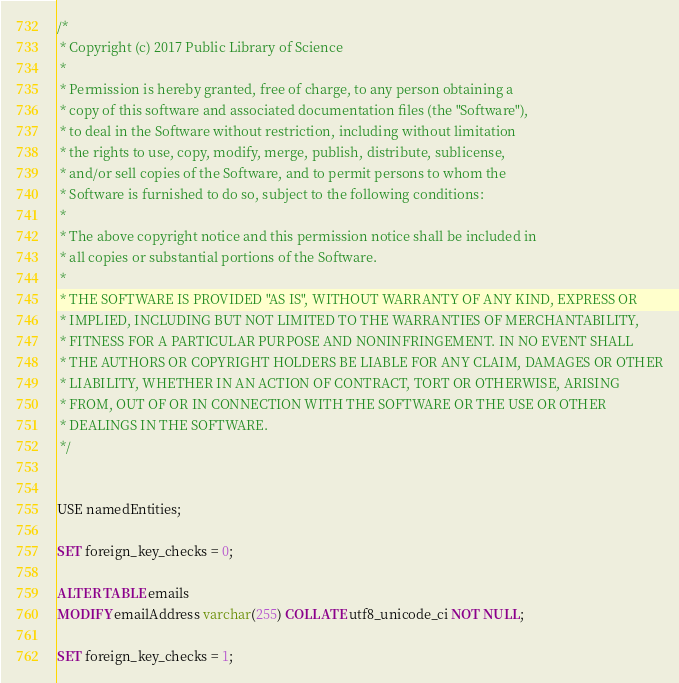Convert code to text. <code><loc_0><loc_0><loc_500><loc_500><_SQL_>/*
 * Copyright (c) 2017 Public Library of Science
 *
 * Permission is hereby granted, free of charge, to any person obtaining a
 * copy of this software and associated documentation files (the "Software"),
 * to deal in the Software without restriction, including without limitation
 * the rights to use, copy, modify, merge, publish, distribute, sublicense,
 * and/or sell copies of the Software, and to permit persons to whom the
 * Software is furnished to do so, subject to the following conditions:
 *
 * The above copyright notice and this permission notice shall be included in
 * all copies or substantial portions of the Software.
 *
 * THE SOFTWARE IS PROVIDED "AS IS", WITHOUT WARRANTY OF ANY KIND, EXPRESS OR
 * IMPLIED, INCLUDING BUT NOT LIMITED TO THE WARRANTIES OF MERCHANTABILITY,
 * FITNESS FOR A PARTICULAR PURPOSE AND NONINFRINGEMENT. IN NO EVENT SHALL
 * THE AUTHORS OR COPYRIGHT HOLDERS BE LIABLE FOR ANY CLAIM, DAMAGES OR OTHER
 * LIABILITY, WHETHER IN AN ACTION OF CONTRACT, TORT OR OTHERWISE, ARISING
 * FROM, OUT OF OR IN CONNECTION WITH THE SOFTWARE OR THE USE OR OTHER
 * DEALINGS IN THE SOFTWARE.
 */


USE namedEntities;

SET foreign_key_checks = 0;

ALTER TABLE emails
MODIFY emailAddress varchar(255) COLLATE utf8_unicode_ci NOT NULL;

SET foreign_key_checks = 1;
</code> 